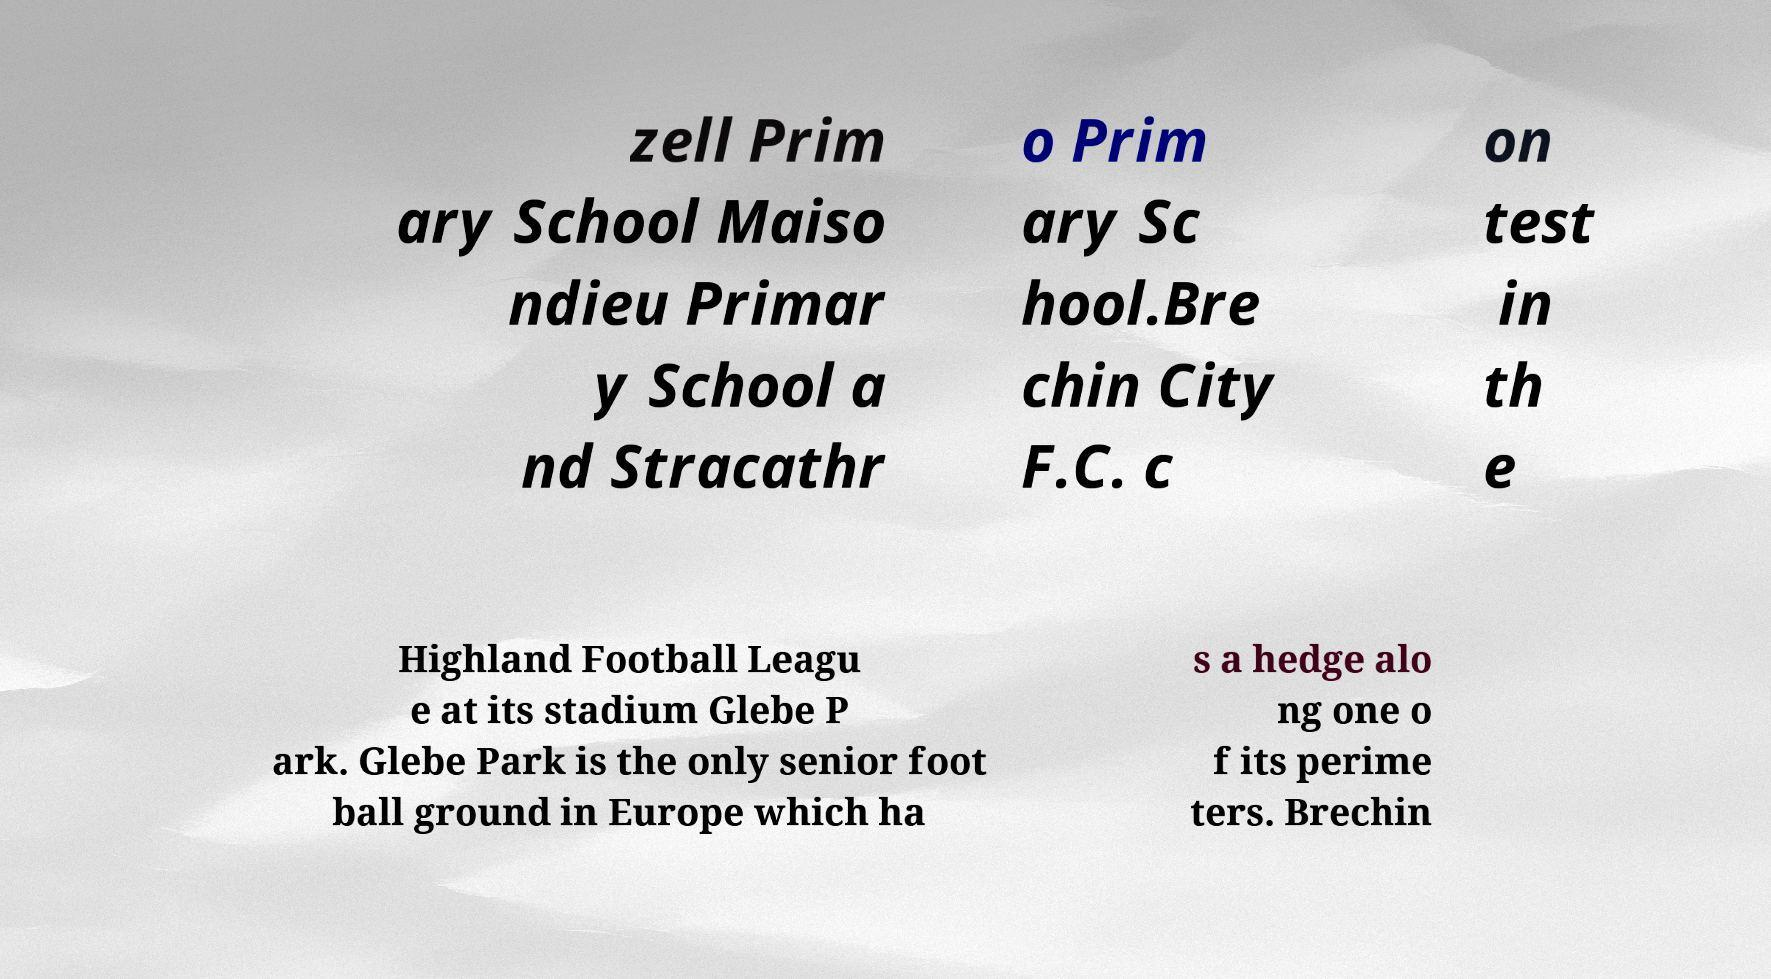Could you extract and type out the text from this image? zell Prim ary School Maiso ndieu Primar y School a nd Stracathr o Prim ary Sc hool.Bre chin City F.C. c on test in th e Highland Football Leagu e at its stadium Glebe P ark. Glebe Park is the only senior foot ball ground in Europe which ha s a hedge alo ng one o f its perime ters. Brechin 